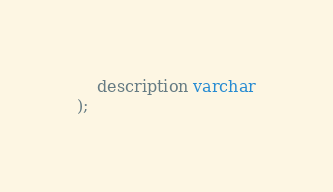<code> <loc_0><loc_0><loc_500><loc_500><_SQL_>    description varchar
);

</code> 